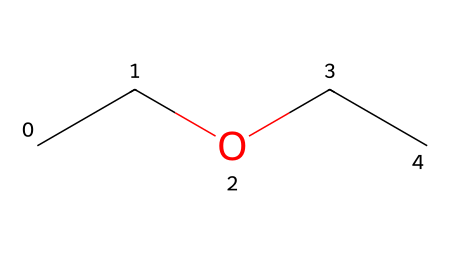What is the name of this chemical? The provided SMILES representation indicates that the structure contains two carbon atoms next to each other (CC), attached to an oxygen atom (O) and then another two carbon atoms (CC). This corresponds to the structure of ethyl ether, which is a common ether.
Answer: ethyl ether How many carbon atoms are present in this molecule? By analyzing the SMILES representation (CCOCC), we can count the number of carbon (C) symbols. There are four carbon atoms in total: two in the first part (CC) and two in the second part (CC).
Answer: four What type of functional group is present in this chemical? The structure includes an oxygen atom between two carbon chains, which is characteristic of ethers. Ethers are defined by their functional group R-O-R' (where R and R' are carbon-containing groups).
Answer: ether How many hydrogen atoms are in the ethyl ether structure? In the structure (CCOCC), each carbon atom typically forms four bonds. The hydrogens will fill the remaining bonds. For four carbons, we can calculate the total number of hydrogens as follows: 4 carbons have 4 bonds each (16 total bonds), and there are 1 oxygen atom which uses 2 of those bonds; hence we have (16 - 2) = 14 hydrogen atoms.
Answer: fourteen Is ethyl ether polar or nonpolar? Ethers generally have a polar C-O bond but are classified as nonpolar overall due to their hydrocarbon chains. The structure features two ethyl groups surrounding an oxygen, contributing to nonpolarity.
Answer: nonpolar 